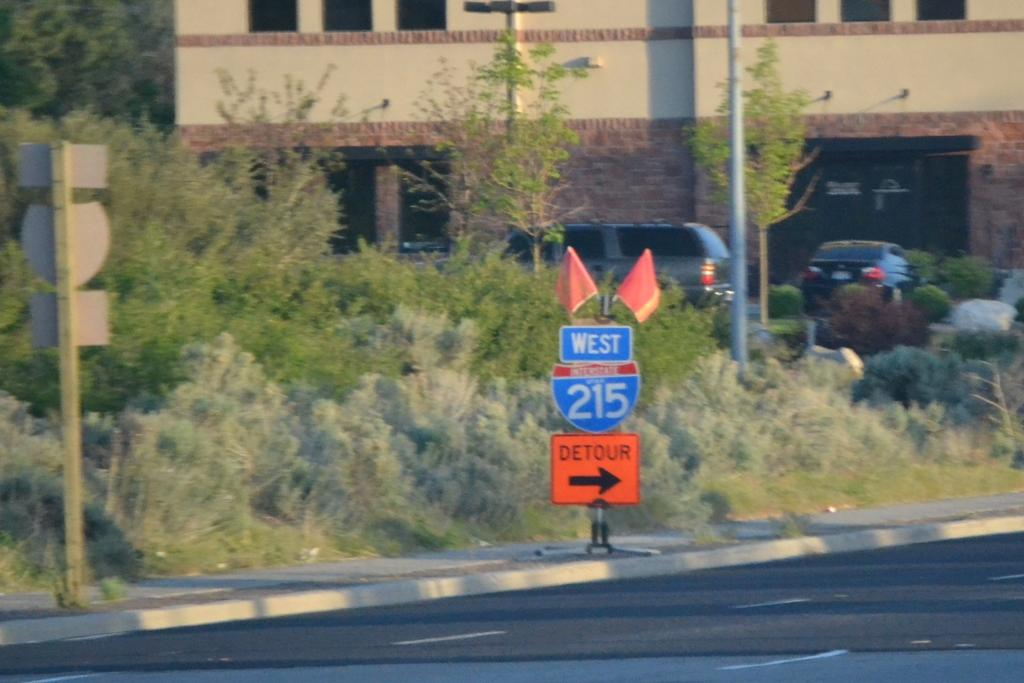<image>
Offer a succinct explanation of the picture presented. An orange detour sign giving an alternate route for West 215. 